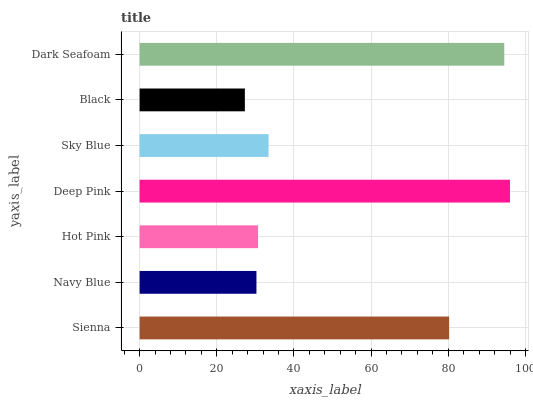Is Black the minimum?
Answer yes or no. Yes. Is Deep Pink the maximum?
Answer yes or no. Yes. Is Navy Blue the minimum?
Answer yes or no. No. Is Navy Blue the maximum?
Answer yes or no. No. Is Sienna greater than Navy Blue?
Answer yes or no. Yes. Is Navy Blue less than Sienna?
Answer yes or no. Yes. Is Navy Blue greater than Sienna?
Answer yes or no. No. Is Sienna less than Navy Blue?
Answer yes or no. No. Is Sky Blue the high median?
Answer yes or no. Yes. Is Sky Blue the low median?
Answer yes or no. Yes. Is Navy Blue the high median?
Answer yes or no. No. Is Deep Pink the low median?
Answer yes or no. No. 